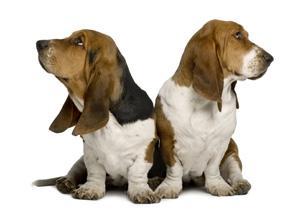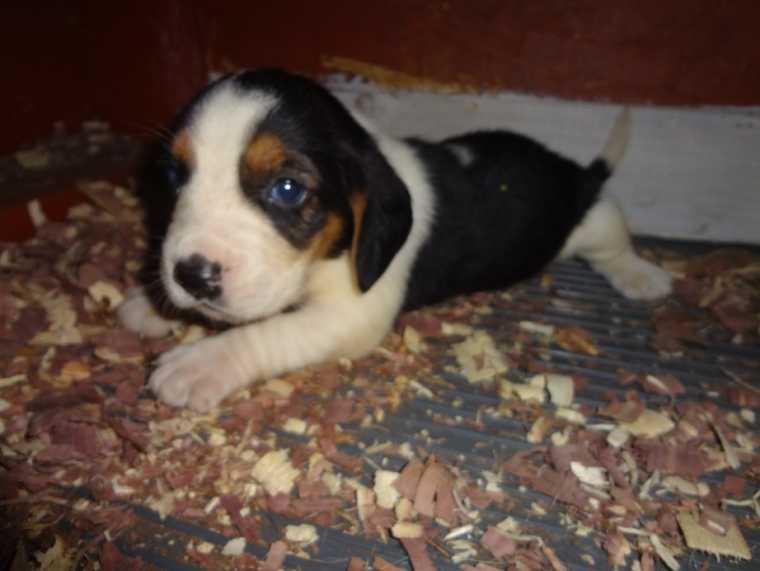The first image is the image on the left, the second image is the image on the right. Considering the images on both sides, is "All the dogs are bloodhounds." valid? Answer yes or no. No. The first image is the image on the left, the second image is the image on the right. Given the left and right images, does the statement "Each image contains exactly one dog, and all dogs are long-eared basset hounds that gaze forward." hold true? Answer yes or no. No. 